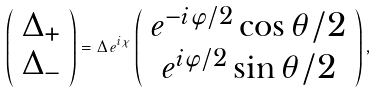Convert formula to latex. <formula><loc_0><loc_0><loc_500><loc_500>\left ( \begin{array} { c } \Delta _ { + } \\ \Delta _ { - } \end{array} \right ) = \Delta \, e ^ { i \chi } \left ( \begin{array} { c } e ^ { - i \varphi / 2 } \cos { \theta / 2 } \\ e ^ { i \varphi / 2 } \sin { \theta / 2 } \end{array} \right ) ,</formula> 